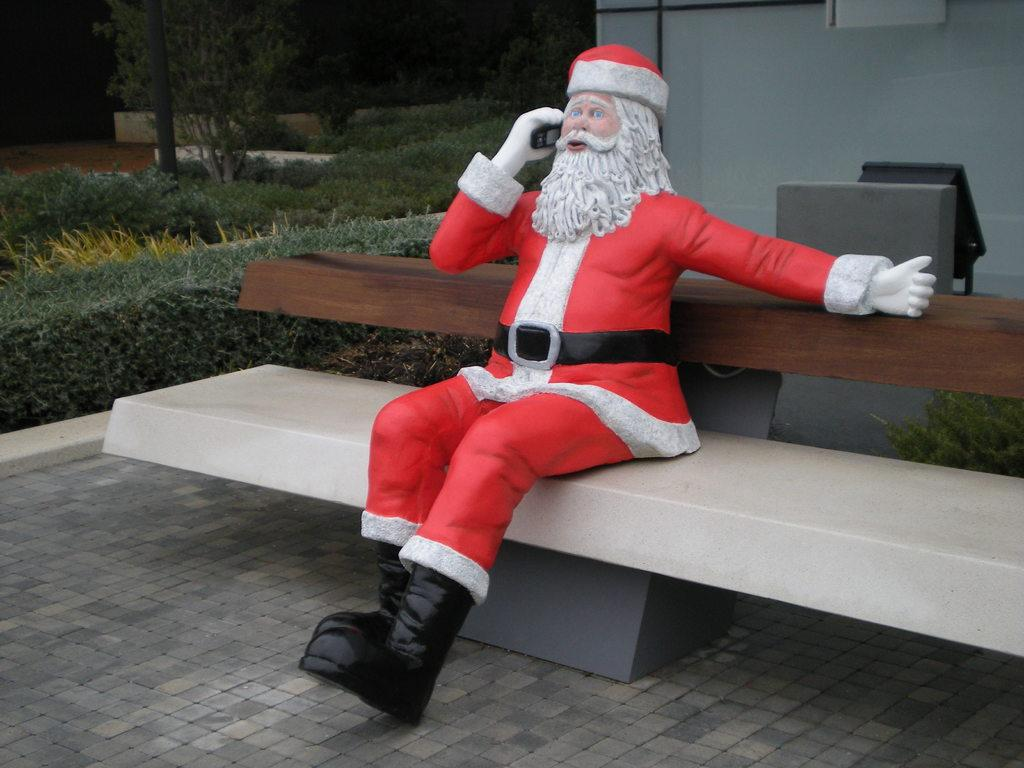What is the main subject of the image? There is a Santa Claus statue in the image. Where is the Santa Claus statue located? The statue is on a bench. What other elements can be seen in the image besides the Santa Claus statue? There are plants in the image. Can you describe any other objects or elements in the image? There are other unspecified objects or elements in the image. How many goldfish are swimming in the dirt in the image? There are no goldfish or dirt present in the image. What type of oranges can be seen hanging from the Santa Claus statue? There are no oranges present in the image, and they are not hanging from the Santa Claus statue. 